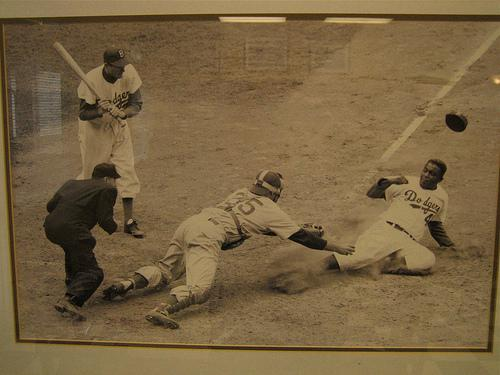Question: where was the photo taken?
Choices:
A. A Football Field.
B. A baseball field.
C. A basketball court.
D. A tennis court.
Answer with the letter. Answer: B Question: what is white?
Choices:
A. A sheet.
B. Paper towels.
C. Line on dirt.
D. Sugar.
Answer with the letter. Answer: C Question: what does the framed picture show?
Choices:
A. A football game.
B. A basketball game.
C. A soccer match.
D. A baseball game.
Answer with the letter. Answer: D Question: who is holding a bat?
Choices:
A. Badmitten player.
B. Baseball player.
C. Cricket player.
D. Tennis player.
Answer with the letter. Answer: B Question: why is a man holding a bat?
Choices:
A. To hit a ball.
B. For practice.
C. To defend himself.
D. To clean it.
Answer with the letter. Answer: A Question: when was the picture taken?
Choices:
A. Night time.
B. In the morning.
C. Afternoon.
D. Daytime.
Answer with the letter. Answer: D Question: what is white?
Choices:
A. Automobile.
B. Player's uniform.
C. Baseball.
D. Signage.
Answer with the letter. Answer: B 